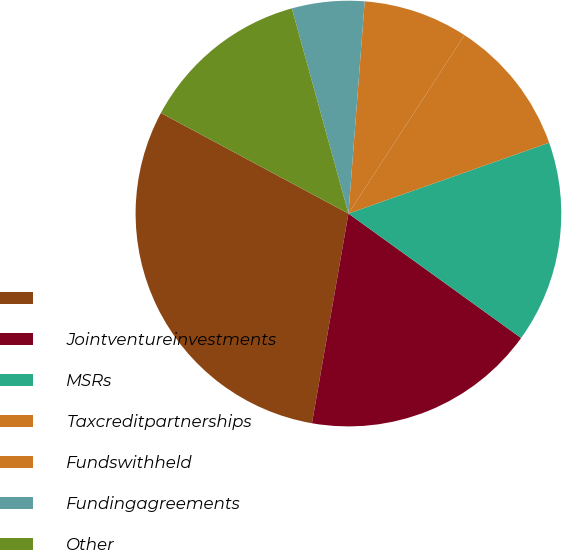Convert chart to OTSL. <chart><loc_0><loc_0><loc_500><loc_500><pie_chart><ecel><fcel>Jointventureinvestments<fcel>MSRs<fcel>Taxcreditpartnerships<fcel>Fundswithheld<fcel>Fundingagreements<fcel>Other<nl><fcel>30.09%<fcel>17.8%<fcel>15.34%<fcel>10.42%<fcel>7.96%<fcel>5.5%<fcel>12.88%<nl></chart> 